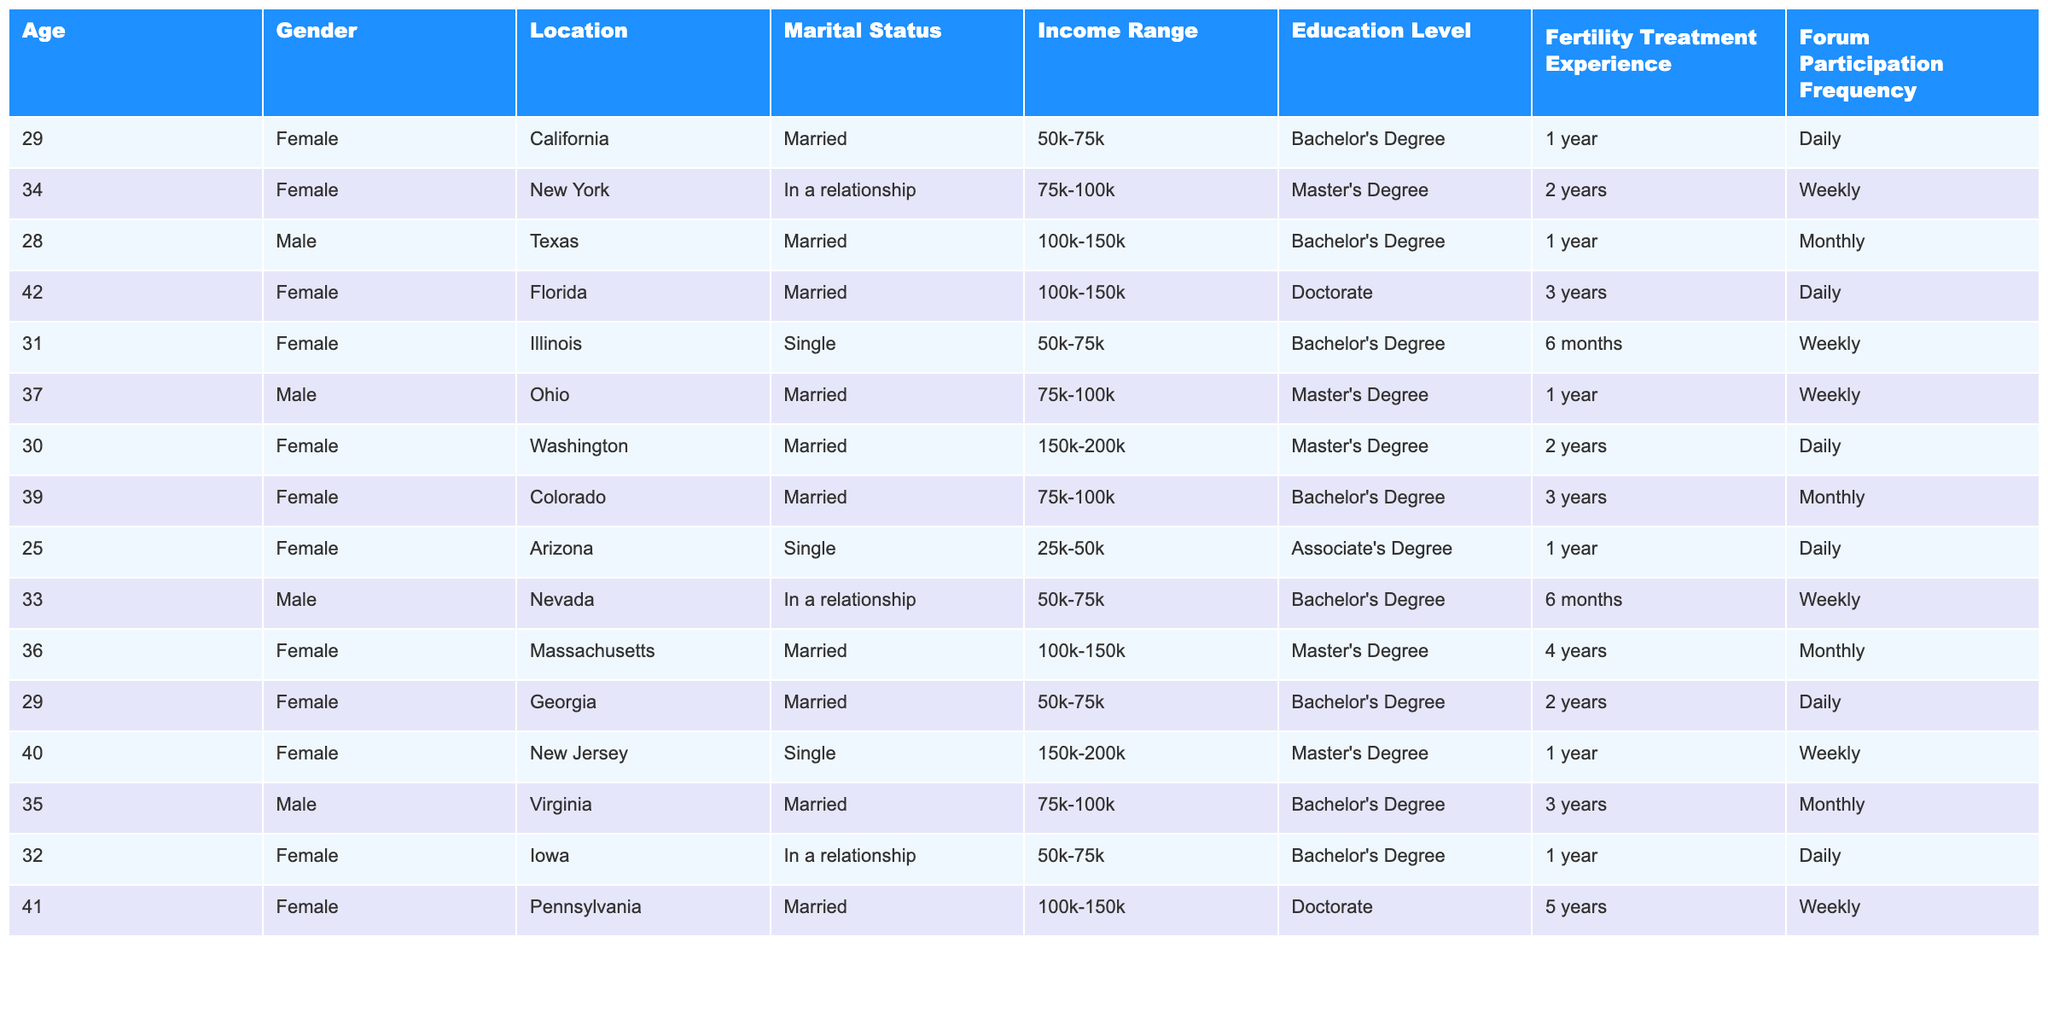What is the age of the individual with the highest education level? The individual with the highest education level is a female from Pennsylvania with a Doctorate, and she is 41 years old.
Answer: 41 How many individuals are married in this dataset? By counting the entries under 'Marital Status', there are 9 individuals marked as married.
Answer: 9 What is the most common income range among those seeking fertility advice? By examining the 'Income Range' column, it appears that the range of 50k-75k is mentioned 5 times, which is more than any other range.
Answer: 50k-75k Is there anyone in the dataset who has over 5 years of fertility treatment experience? Scanning the 'Fertility Treatment Experience' column, the maximum listed experience is 5 years, so there are no individuals with over 5 years of experience.
Answer: No What percentage of individuals are single in this dataset? There are 3 individuals out of the total of 12 who are single, which calculates as (3/12)*100 = 25%.
Answer: 25% Which location has the most individuals participating in forums daily? Checking the 'Forum Participation Frequency', both California and Texas have 3 individuals participating daily, but California has the highest representation in the dataset.
Answer: California What is the average age of individuals seeking fertility advice? The ages of all individuals are 29, 34, 28, 42, 31, 37, 30, 39, 25, 33, 36, 29, 40, 35, 32, and 41, totaling 29+34+28+42+31+37+30+39+25+33+36+29 + 40 + 35 + 32 + 41 = 515 years. Dividing by 15 gives an average age of approximately 34.33 years.
Answer: 34.33 How many males have a Master’s degree? Looking at the 'Education Level' column, 2 males hold a Master’s degree (one from Ohio and one from Texas).
Answer: 2 What is the fertility treatment experience of the individual located in Florida? The individual from Florida is a female with 3 years of fertility treatment experience.
Answer: 3 years Are there more individuals who have participated weekly in forums than those who have participated monthly? There are 6 individuals participating weekly and 4 participating monthly, so there are indeed more participants in the weekly category.
Answer: Yes Which income range is associated with the highest education level? The individuals with the highest education level (Doctorate) have incomes in the 100k-150k range (two individuals in two separate entries).
Answer: 100k-150k 